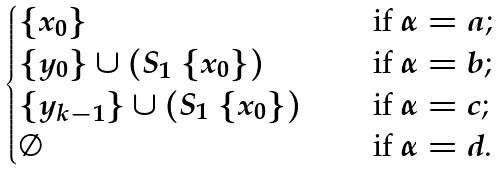<formula> <loc_0><loc_0><loc_500><loc_500>\begin{cases} \{ x _ { 0 } \} & \quad \text { if $\alpha = a$; } \\ \{ y _ { 0 } \} \cup ( S _ { 1 } \ \{ x _ { 0 } \} ) & \quad \text { if $\alpha = b$; } \\ \{ y _ { k - 1 } \} \cup ( S _ { 1 } \ \{ x _ { 0 } \} ) & \quad \text { if $\alpha = c$; } \\ \emptyset & \quad \text { if $\alpha = d$. } \end{cases}</formula> 